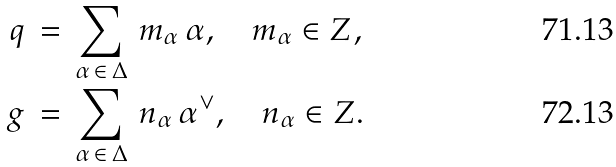<formula> <loc_0><loc_0><loc_500><loc_500>q & \, = \, \sum _ { \alpha \, \in \, \Delta } \, m _ { \alpha } \, \alpha , \quad m _ { \alpha } \in { Z } , \\ g & \, = \, \sum _ { \alpha \, \in \, \Delta } \, n _ { \alpha } \, \alpha ^ { \vee } , \quad n _ { \alpha } \in { Z } .</formula> 